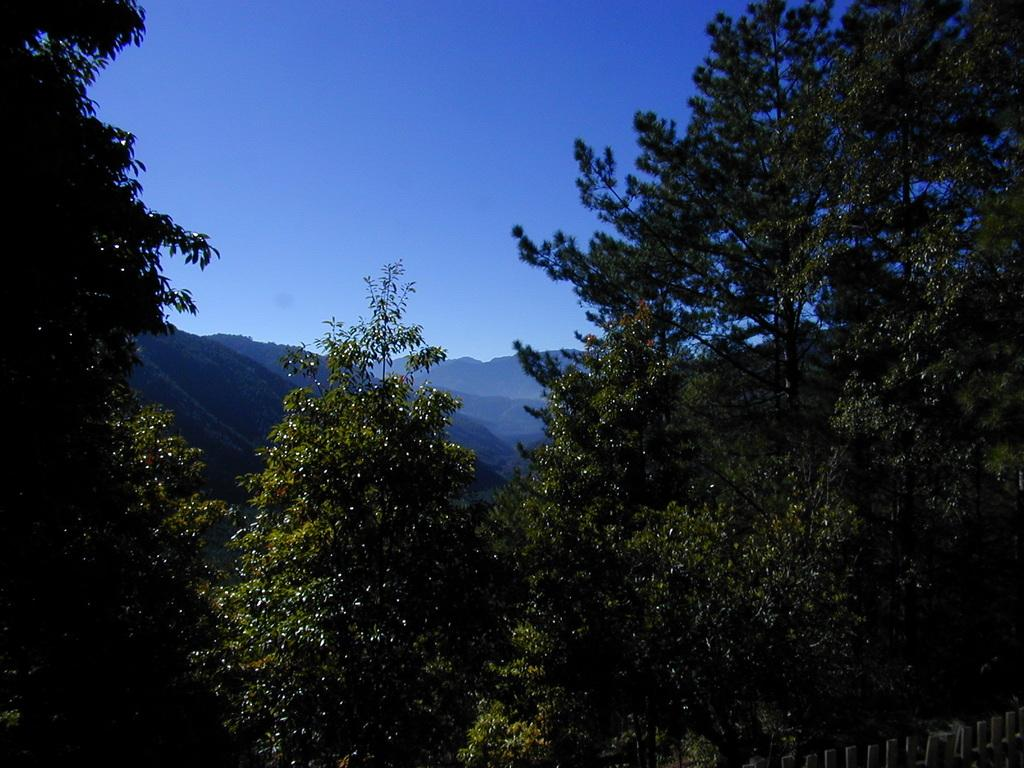What type of vegetation is visible in the front of the image? There are trees in the front of the image. What type of natural feature can be seen in the background of the image? There are mountains in the background of the image. What type of barrier is present on the bottom right of the image? There is a wooden fence on the bottom right of the image. Can you see any structures in the image? There is no specific structure mentioned in the provided facts, but the wooden fence could be considered a type of structure. Are there any eyes visible in the image? There are no eyes present in the image. 